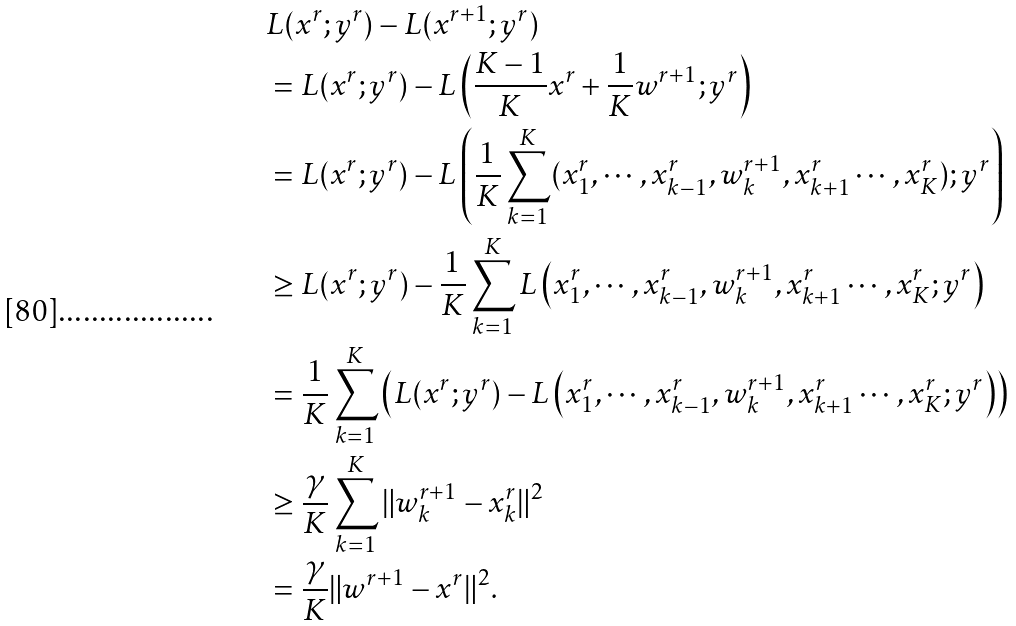Convert formula to latex. <formula><loc_0><loc_0><loc_500><loc_500>& L ( x ^ { r } ; y ^ { r } ) - L ( x ^ { r + 1 } ; y ^ { r } ) \\ & = L ( x ^ { r } ; y ^ { r } ) - L \left ( \frac { K - 1 } { K } x ^ { r } + \frac { 1 } { K } w ^ { r + 1 } ; y ^ { r } \right ) \\ & = L ( x ^ { r } ; y ^ { r } ) - L \left ( \frac { 1 } { K } \sum _ { k = 1 } ^ { K } ( x ^ { r } _ { 1 } , \cdots , x ^ { r } _ { k - 1 } , w ^ { r + 1 } _ { k } , x ^ { r } _ { k + 1 } \cdots , x ^ { r } _ { K } ) ; y ^ { r } \right ) \\ & \geq L ( x ^ { r } ; y ^ { r } ) - \frac { 1 } { K } \sum _ { k = 1 } ^ { K } L \left ( x ^ { r } _ { 1 } , \cdots , x ^ { r } _ { k - 1 } , w ^ { r + 1 } _ { k } , x ^ { r } _ { k + 1 } \cdots , x ^ { r } _ { K } ; y ^ { r } \right ) \\ & = \frac { 1 } { K } \sum _ { k = 1 } ^ { K } \left ( L ( x ^ { r } ; y ^ { r } ) - L \left ( x ^ { r } _ { 1 } , \cdots , x ^ { r } _ { k - 1 } , w ^ { r + 1 } _ { k } , x ^ { r } _ { k + 1 } \cdots , x ^ { r } _ { K } ; y ^ { r } \right ) \right ) \\ & \geq \frac { \gamma } { K } \sum _ { k = 1 } ^ { K } \| w ^ { r + 1 } _ { k } - x ^ { r } _ { k } \| ^ { 2 } \\ & = \frac { \gamma } { K } \| w ^ { r + 1 } - x ^ { r } \| ^ { 2 } .</formula> 